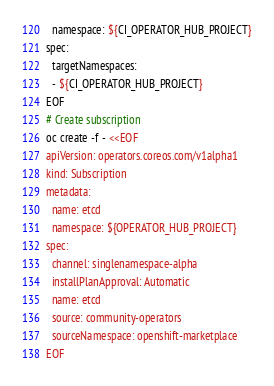<code> <loc_0><loc_0><loc_500><loc_500><_Bash_>  namespace: ${CI_OPERATOR_HUB_PROJECT}
spec:
  targetNamespaces:
  - ${CI_OPERATOR_HUB_PROJECT}
EOF
# Create subscription
oc create -f - <<EOF
apiVersion: operators.coreos.com/v1alpha1
kind: Subscription
metadata:
  name: etcd
  namespace: ${OPERATOR_HUB_PROJECT}
spec:
  channel: singlenamespace-alpha
  installPlanApproval: Automatic
  name: etcd
  source: community-operators
  sourceNamespace: openshift-marketplace
EOF
</code> 